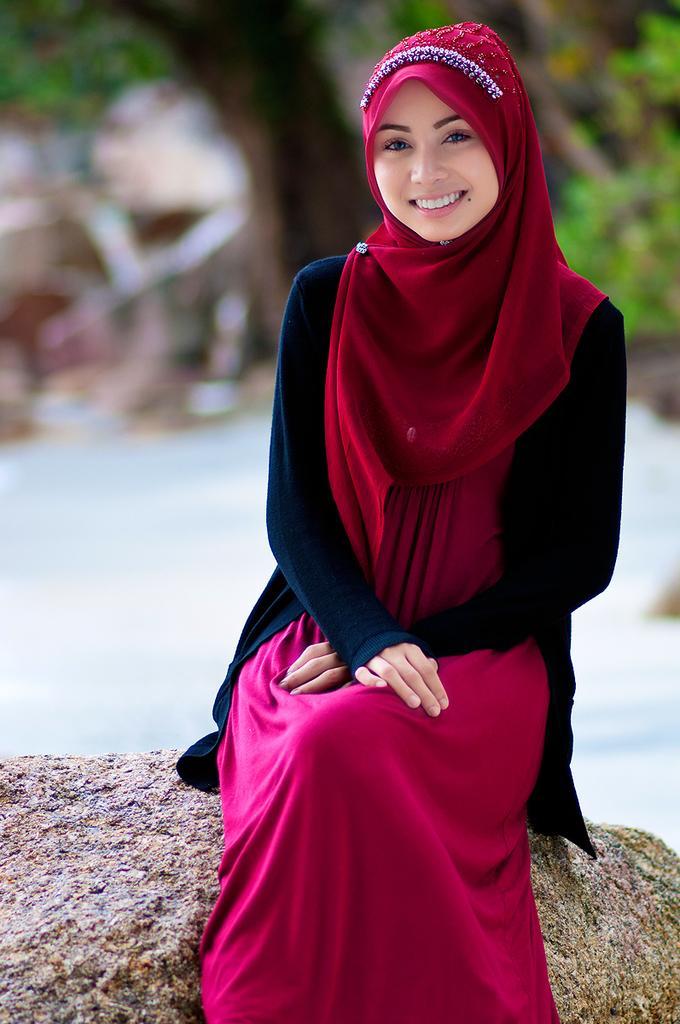Please provide a concise description of this image. In this image in the foreground there is one woman who is sitting and smiling, and in the background there are some trees and houses. 